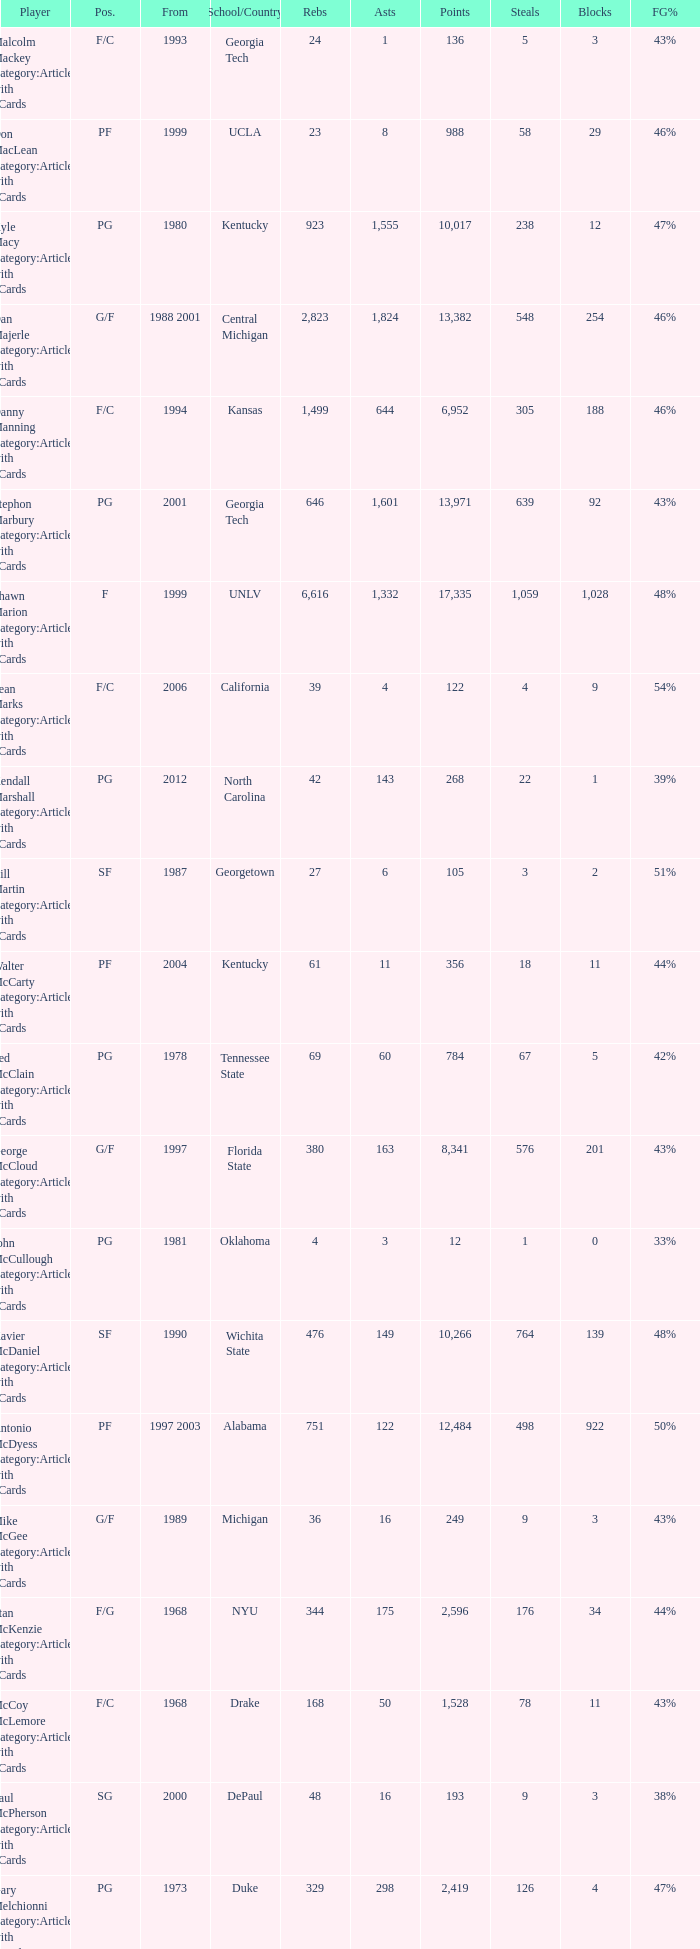What position does the player from arkansas play? C. 